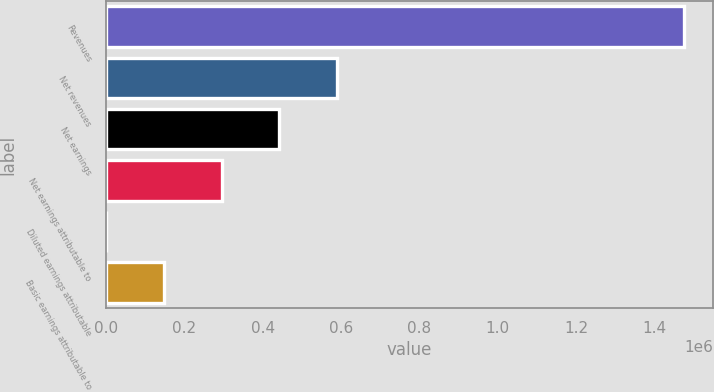<chart> <loc_0><loc_0><loc_500><loc_500><bar_chart><fcel>Revenues<fcel>Net revenues<fcel>Net earnings<fcel>Net earnings attributable to<fcel>Diluted earnings attributable<fcel>Basic earnings attributable to<nl><fcel>1.47516e+06<fcel>590066<fcel>442550<fcel>295033<fcel>0.63<fcel>147517<nl></chart> 